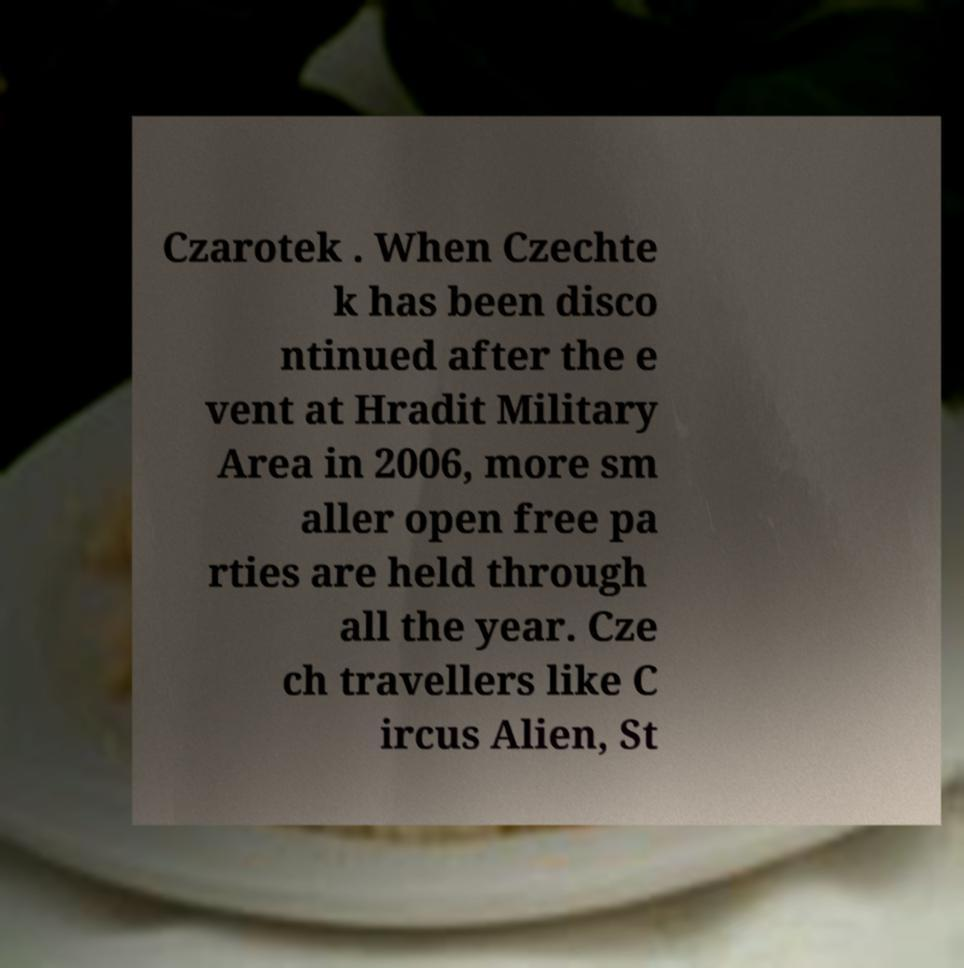There's text embedded in this image that I need extracted. Can you transcribe it verbatim? Czarotek . When Czechte k has been disco ntinued after the e vent at Hradit Military Area in 2006, more sm aller open free pa rties are held through all the year. Cze ch travellers like C ircus Alien, St 